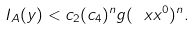Convert formula to latex. <formula><loc_0><loc_0><loc_500><loc_500>I _ { A } ( y ) < c _ { 2 } ( c _ { 4 } ) ^ { n } g ( \ x x ^ { 0 } ) ^ { n } .</formula> 